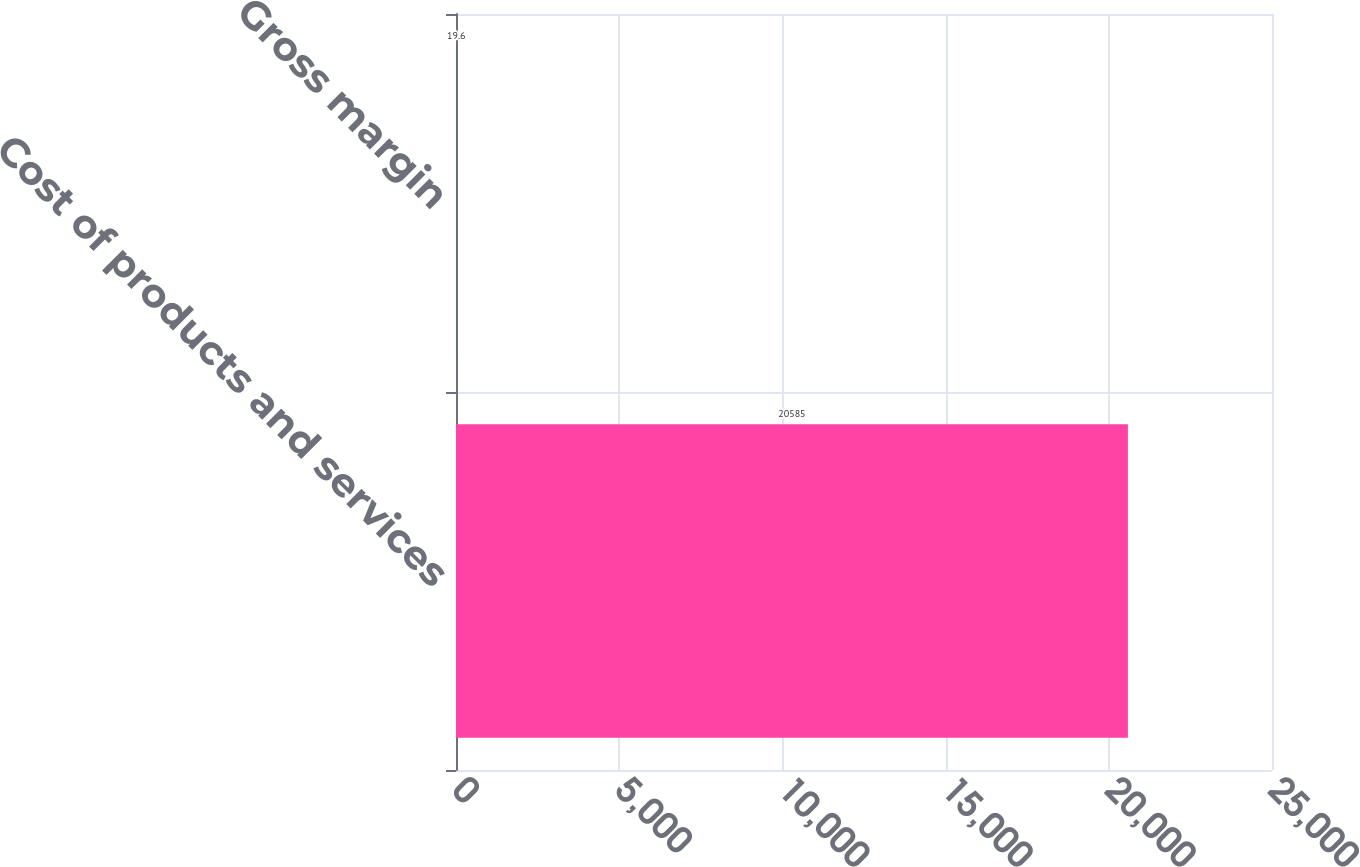<chart> <loc_0><loc_0><loc_500><loc_500><bar_chart><fcel>Cost of products and services<fcel>Gross margin<nl><fcel>20585<fcel>19.6<nl></chart> 